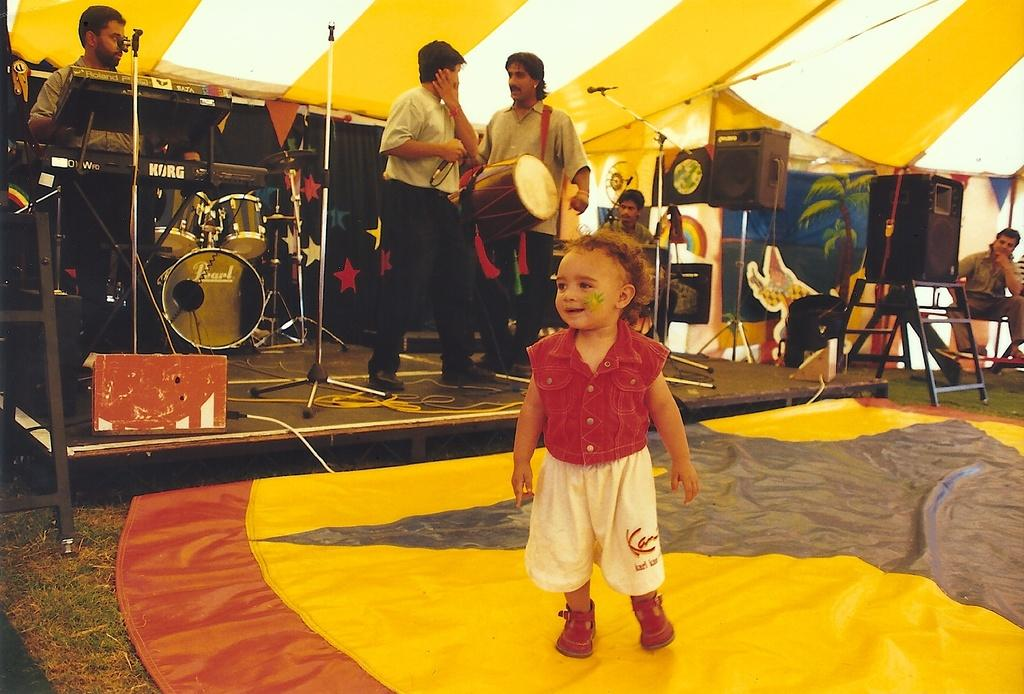What is the main subject of the image? The main subject of the image is a boy standing in the middle of the image. What is the boy doing in the image? The boy is standing in the middle of the image. What can be seen on the left side of the image? There is a person playing musical instruments on the left side of the image. What type of cloth is being woven by the boy in the image? There is no cloth or weaving activity present in the image. How many baskets can be seen on the right side of the image? There is no basket present in the image. 